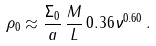Convert formula to latex. <formula><loc_0><loc_0><loc_500><loc_500>\rho _ { 0 } \approx \frac { \Sigma _ { 0 } } { a } \, \frac { M } { L } \, 0 . 3 6 \nu ^ { 0 . 6 0 } \, .</formula> 